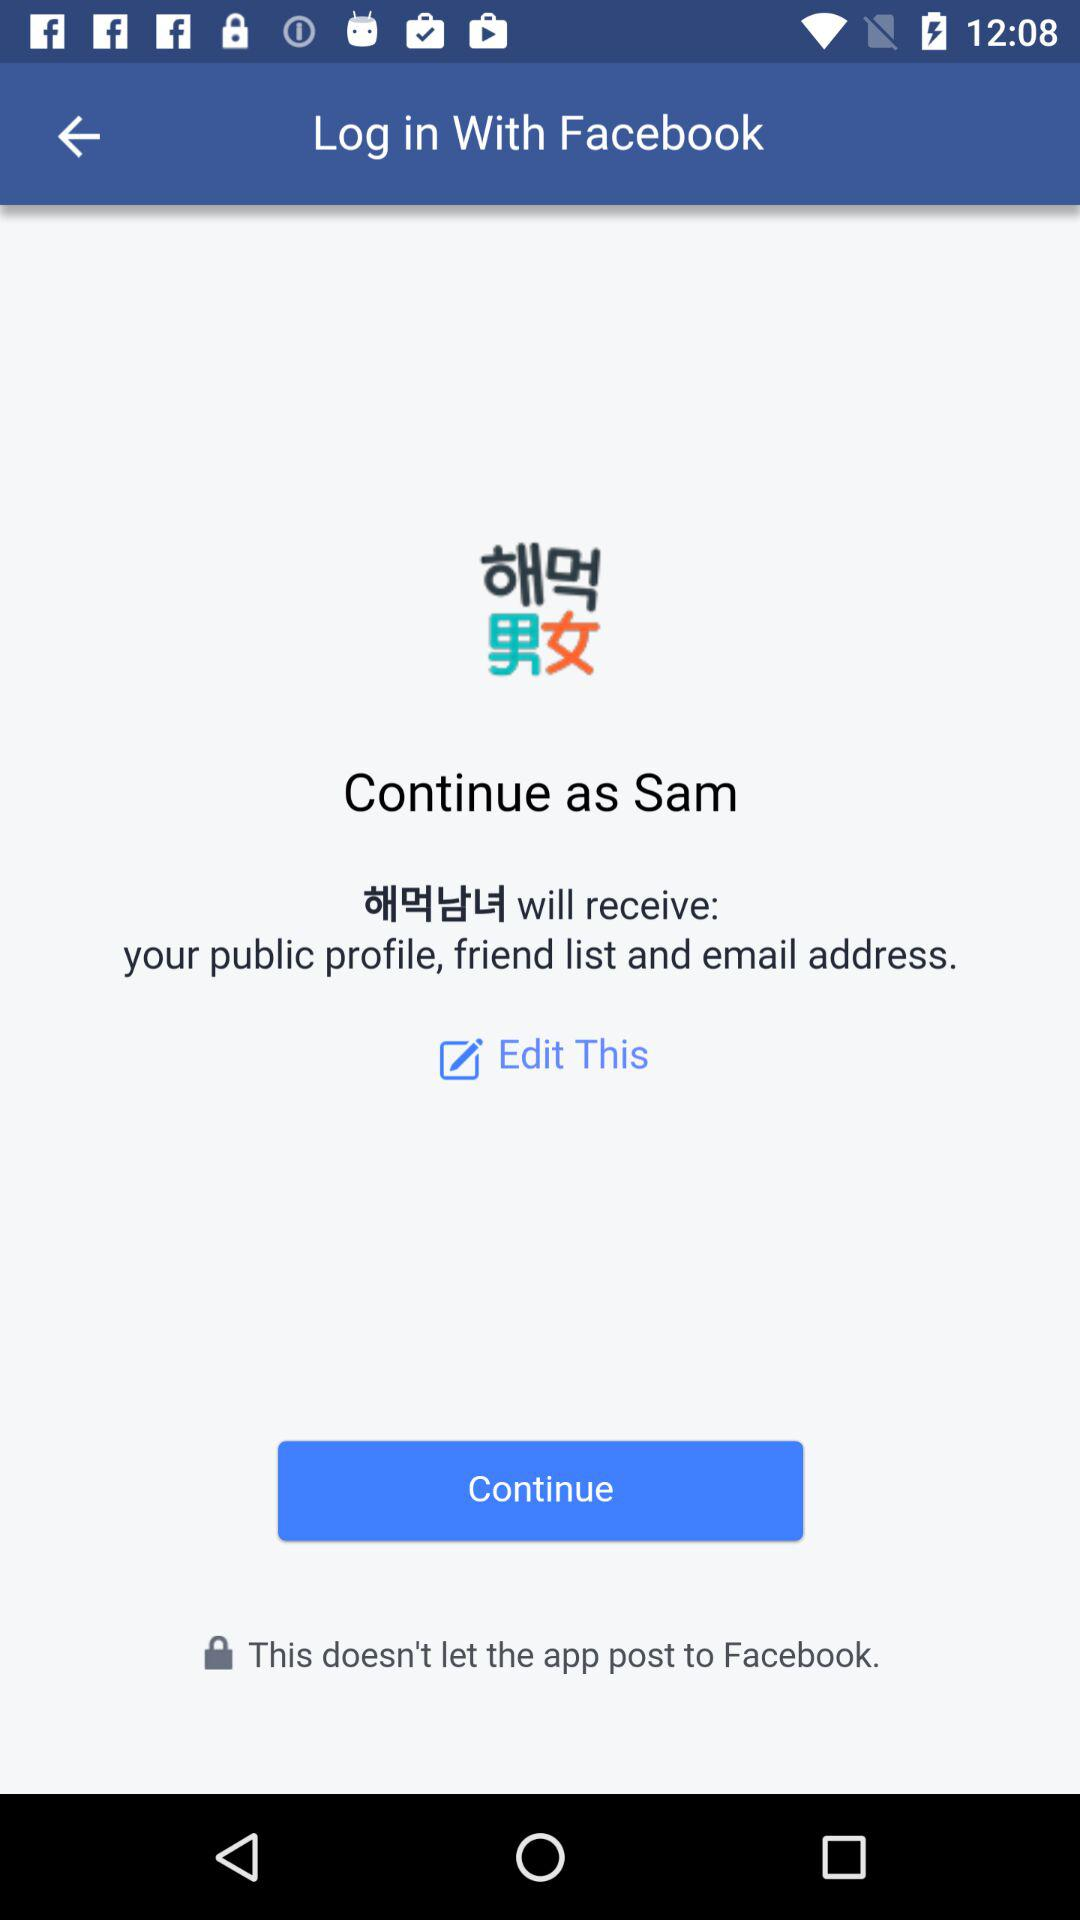Through what account can logging in be done? Logging in can be done through "Facebook". 